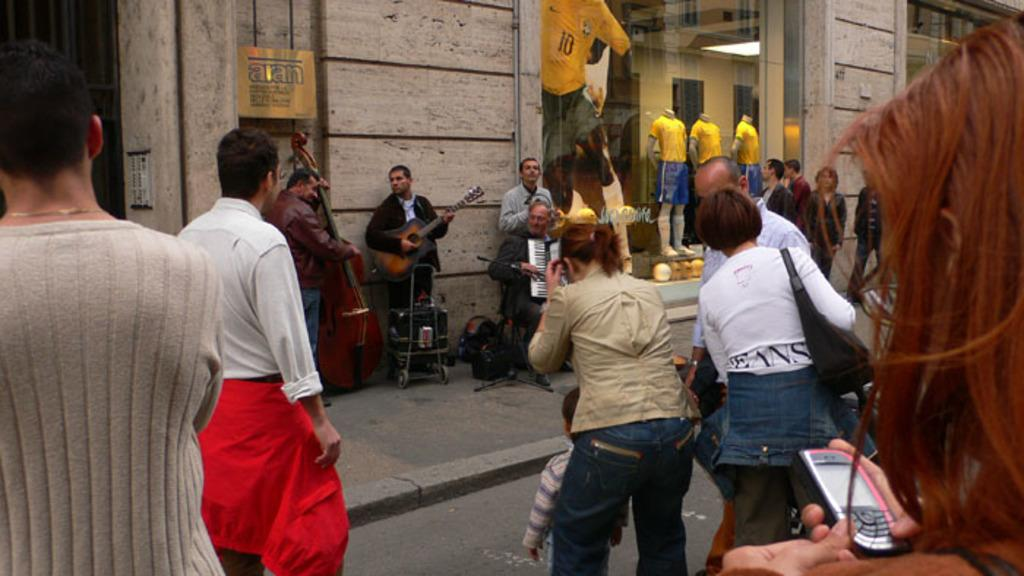What are the people in the image doing? There is a group of people playing/holding musical instruments in the image. Are there any other people in the image besides the musicians? Yes, there is an audience in the image. What type of structure might be visible through the glass window in the image? The glass window in the image might be part of a building or venue. What can be seen in the background of the image? In the image, there is a road and a wall visible in the background. How far can the musical instruments be heard in the image? The range at which the musical instruments can be heard is not present in the image. 